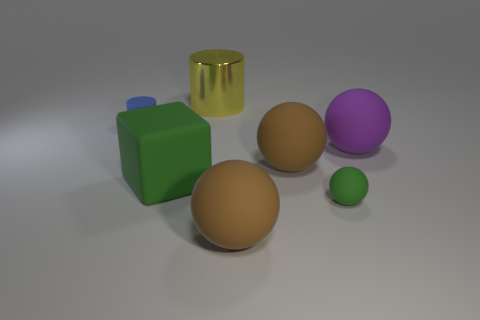There is a big green object that is the same material as the purple ball; what shape is it?
Provide a short and direct response. Cube. What color is the small cylinder that is the same material as the large green block?
Your response must be concise. Blue. How many matte objects are behind the large sphere to the right of the green matte thing right of the yellow shiny cylinder?
Your response must be concise. 1. What is the color of the tiny rubber ball?
Ensure brevity in your answer.  Green. How many other objects are the same size as the matte cylinder?
Your answer should be very brief. 1. There is a tiny object that is the same shape as the big purple thing; what is its material?
Your answer should be compact. Rubber. What is the material of the cylinder that is on the right side of the green object that is left of the big thing behind the purple object?
Make the answer very short. Metal. The cube that is made of the same material as the tiny green ball is what size?
Give a very brief answer. Large. Is there any other thing that is the same color as the tiny cylinder?
Make the answer very short. No. Is the color of the large rubber object on the left side of the large cylinder the same as the tiny matte thing in front of the purple rubber thing?
Keep it short and to the point. Yes. 